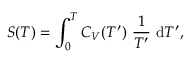Convert formula to latex. <formula><loc_0><loc_0><loc_500><loc_500>S ( T ) = \int _ { 0 } ^ { T } C _ { V } ( T ^ { \prime } ) \frac { 1 } { T ^ { \prime } } d T ^ { \prime } ,</formula> 